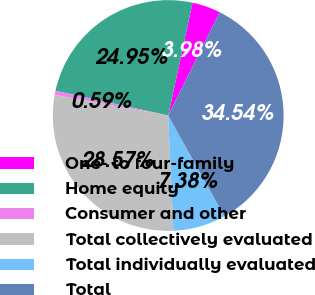Convert chart to OTSL. <chart><loc_0><loc_0><loc_500><loc_500><pie_chart><fcel>One- to four-family<fcel>Home equity<fcel>Consumer and other<fcel>Total collectively evaluated<fcel>Total individually evaluated<fcel>Total<nl><fcel>3.98%<fcel>24.95%<fcel>0.59%<fcel>28.57%<fcel>7.38%<fcel>34.54%<nl></chart> 